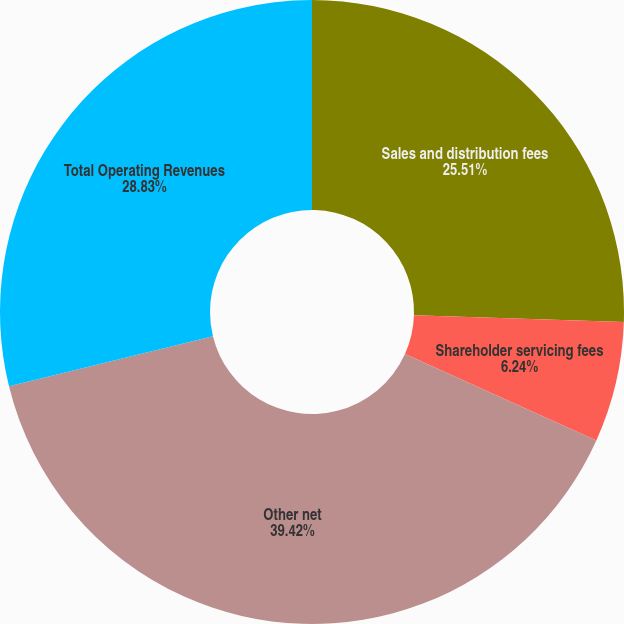<chart> <loc_0><loc_0><loc_500><loc_500><pie_chart><fcel>Sales and distribution fees<fcel>Shareholder servicing fees<fcel>Other net<fcel>Total Operating Revenues<nl><fcel>25.51%<fcel>6.24%<fcel>39.42%<fcel>28.83%<nl></chart> 